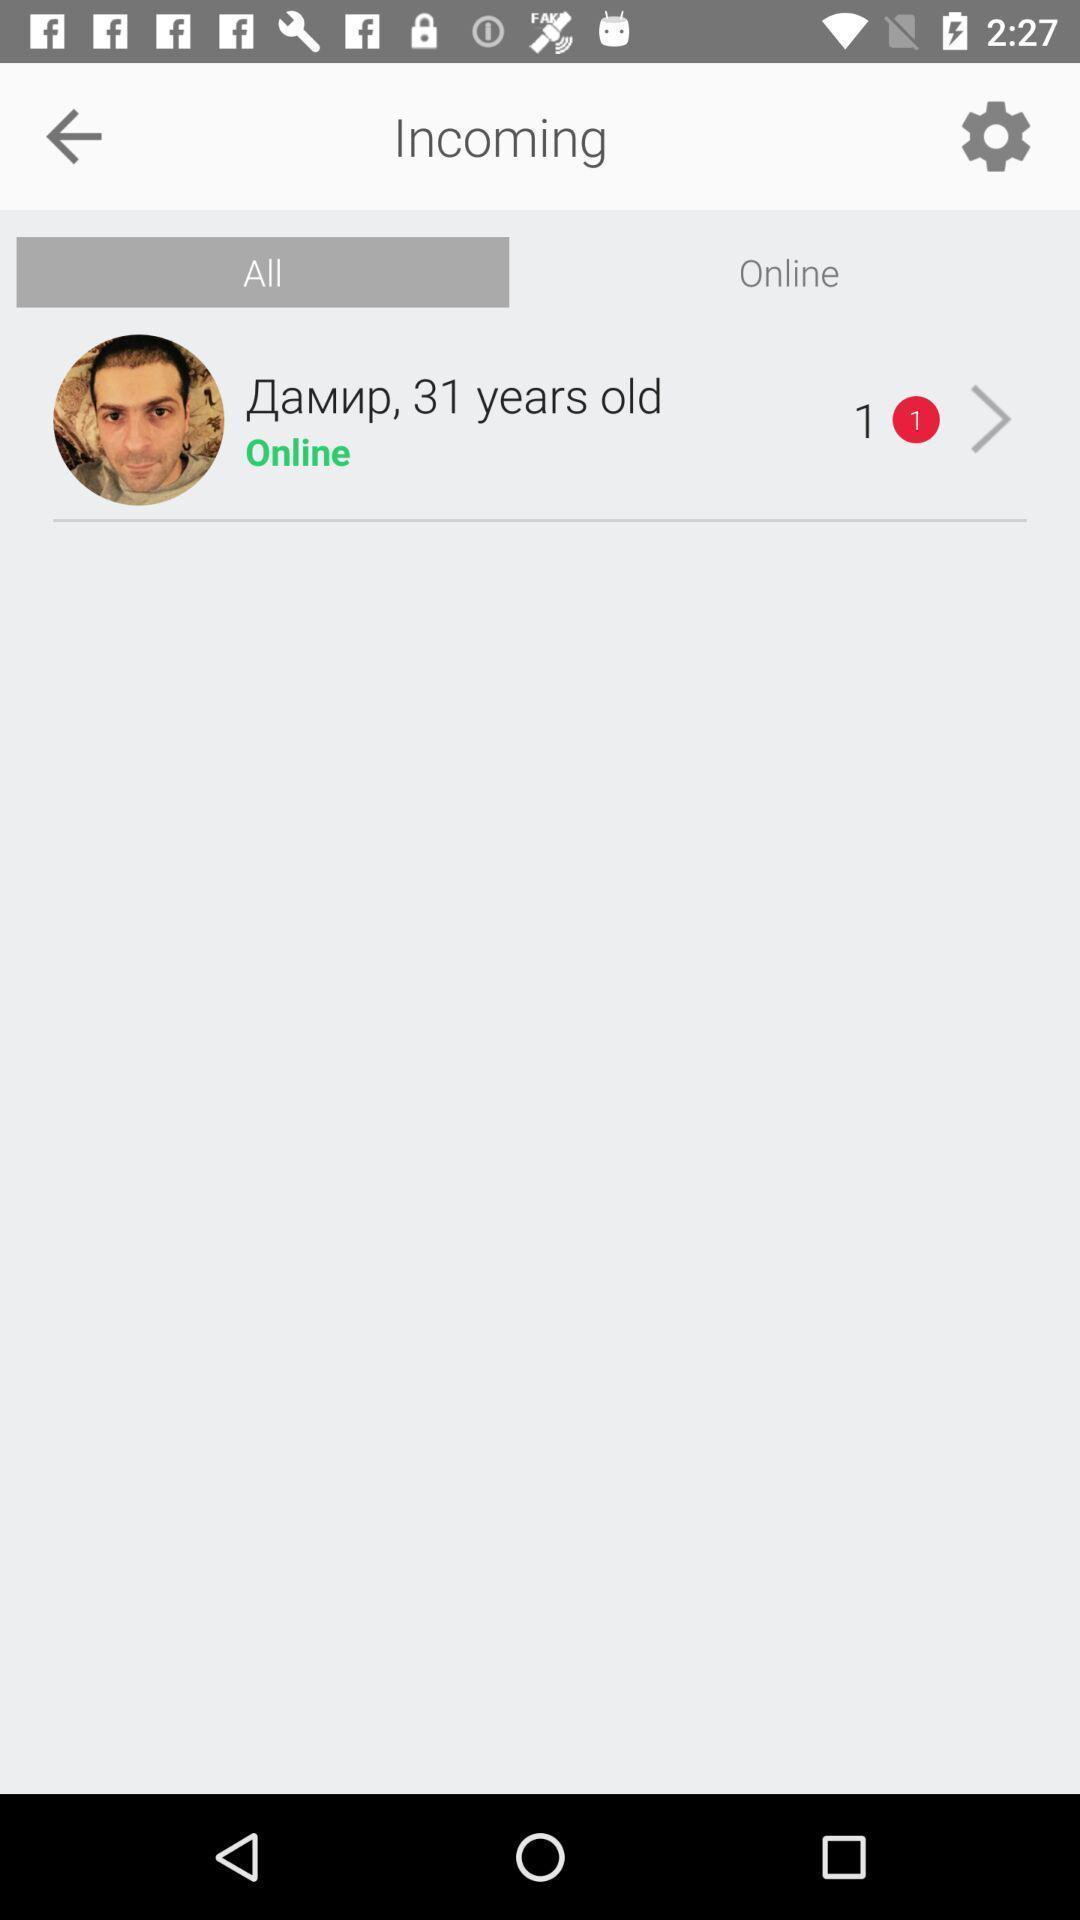Tell me about the visual elements in this screen capture. Page of a dating app showing recent messages. 